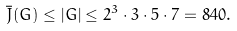<formula> <loc_0><loc_0><loc_500><loc_500>\bar { J } ( G ) \leq | G | \leq 2 ^ { 3 } \cdot 3 \cdot 5 \cdot 7 = 8 4 0 .</formula> 